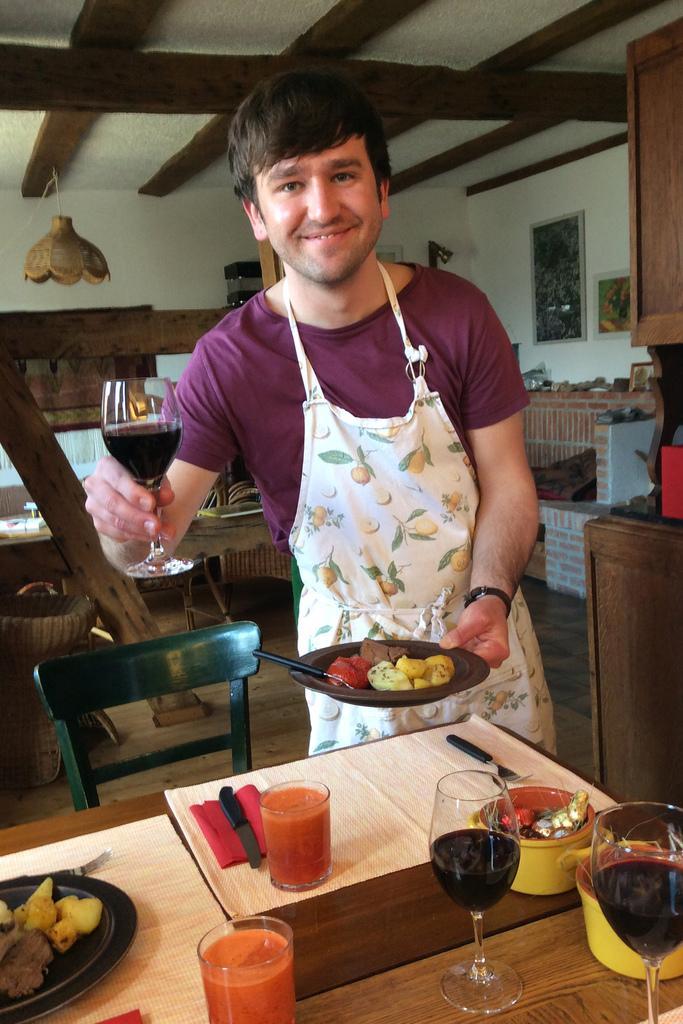Please provide a concise description of this image. In this picture we can see a man who is smiling. He hold a plate and glass with his hands. And this is chair. There is a table, On the table there is a glass, plate and bowl. This is knife. And on the background there is a wall. And this is the roof. And these are the frames on the wall. 